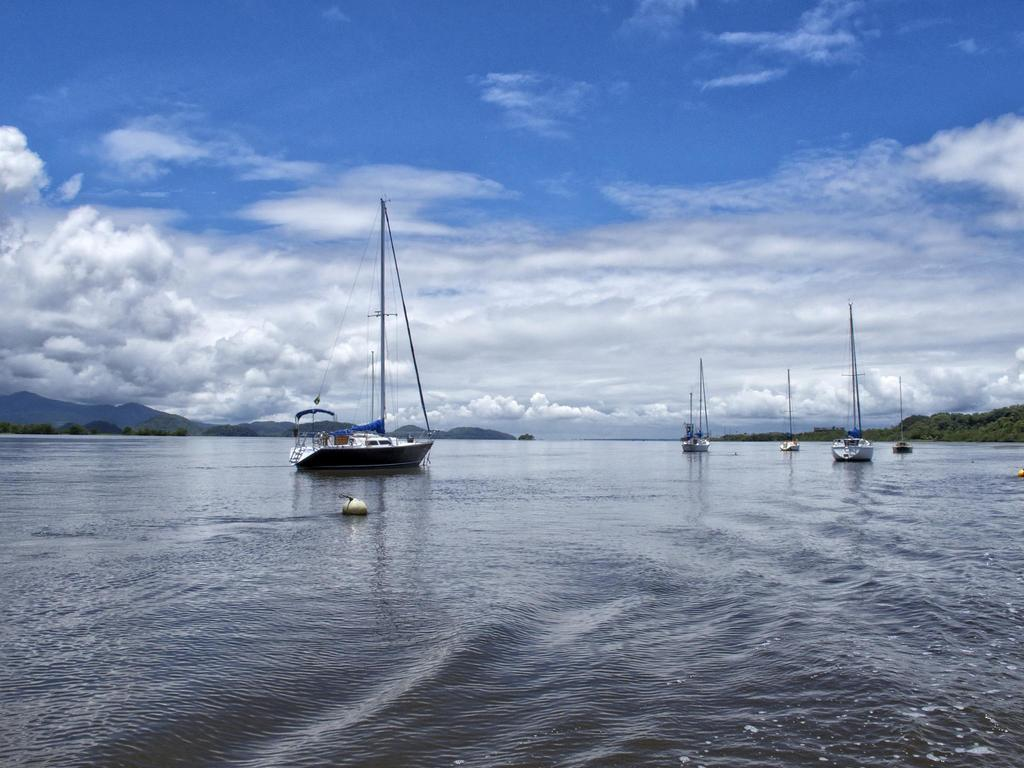What type of vehicles can be seen in the image? There are boats in the image. What color are the boats? The boats are white in color. What is the primary element surrounding the boats? There is water in the image. What can be seen in the distance behind the boats? Mountains and clouds are visible in the background. What is the color of the sky in the image? The sky is blue. How much heat is being generated by the screw in the image? There is no screw present in the image, so it is not possible to determine the amount of heat being generated. 